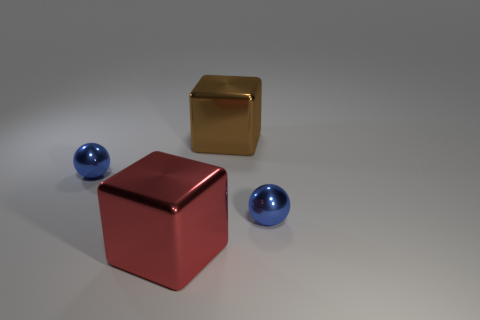Subtract all purple spheres. Subtract all cyan cylinders. How many spheres are left? 2 Subtract all yellow cylinders. How many red cubes are left? 1 Add 1 browns. How many blues exist? 0 Subtract all metallic spheres. Subtract all large brown metal cubes. How many objects are left? 1 Add 4 big brown shiny cubes. How many big brown shiny cubes are left? 5 Add 4 blue spheres. How many blue spheres exist? 6 Add 4 big red metallic things. How many objects exist? 8 Subtract all red cubes. How many cubes are left? 1 Subtract 1 brown cubes. How many objects are left? 3 How many blue balls must be subtracted to get 1 blue balls? 1 